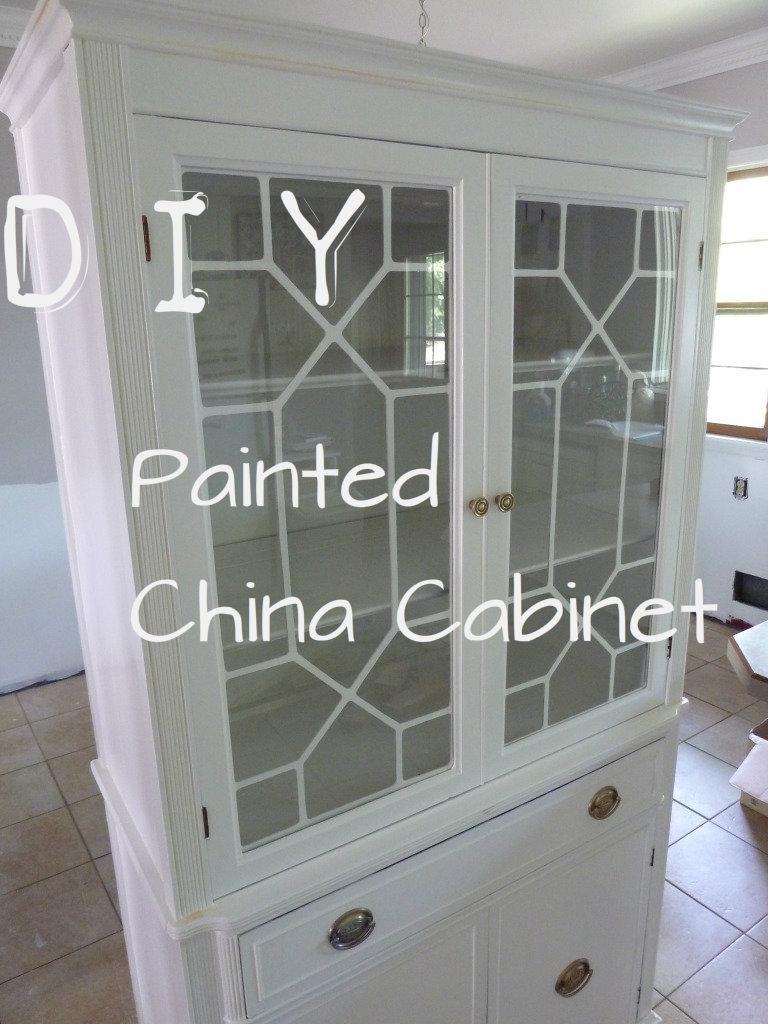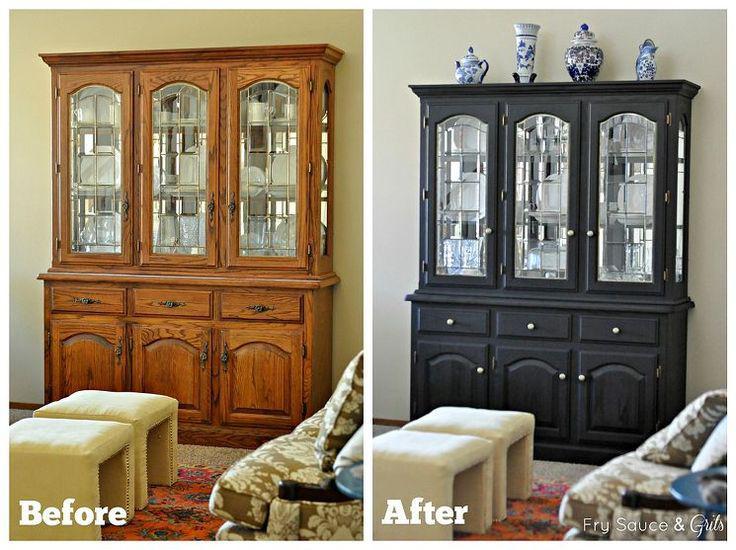The first image is the image on the left, the second image is the image on the right. Considering the images on both sides, is "The blue colored cabinet is storing things." valid? Answer yes or no. No. The first image is the image on the left, the second image is the image on the right. Considering the images on both sides, is "An image shows exactly one cabinet, which is sky blue." valid? Answer yes or no. No. 